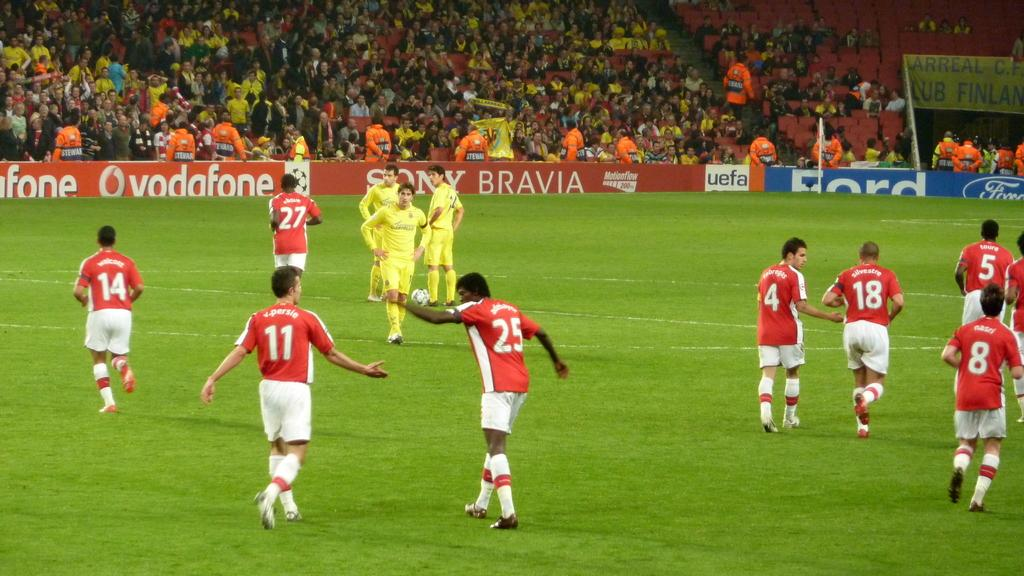What are the people in the image doing? The people in the image are players, and they are walking on a playground. Can you describe the setting of the image? The players are walking on a playground, and there are spectators in the background. What type of toys can be seen in the middle of the image? There are no toys present in the image; it features players walking on a playground with spectators in the background. 